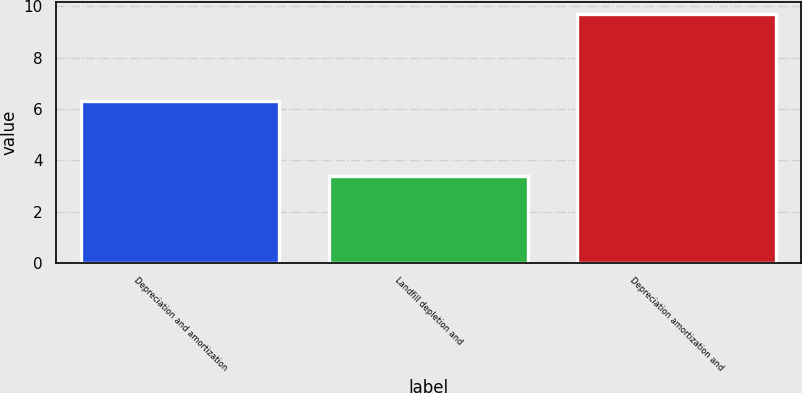<chart> <loc_0><loc_0><loc_500><loc_500><bar_chart><fcel>Depreciation and amortization<fcel>Landfill depletion and<fcel>Depreciation amortization and<nl><fcel>6.3<fcel>3.4<fcel>9.7<nl></chart> 